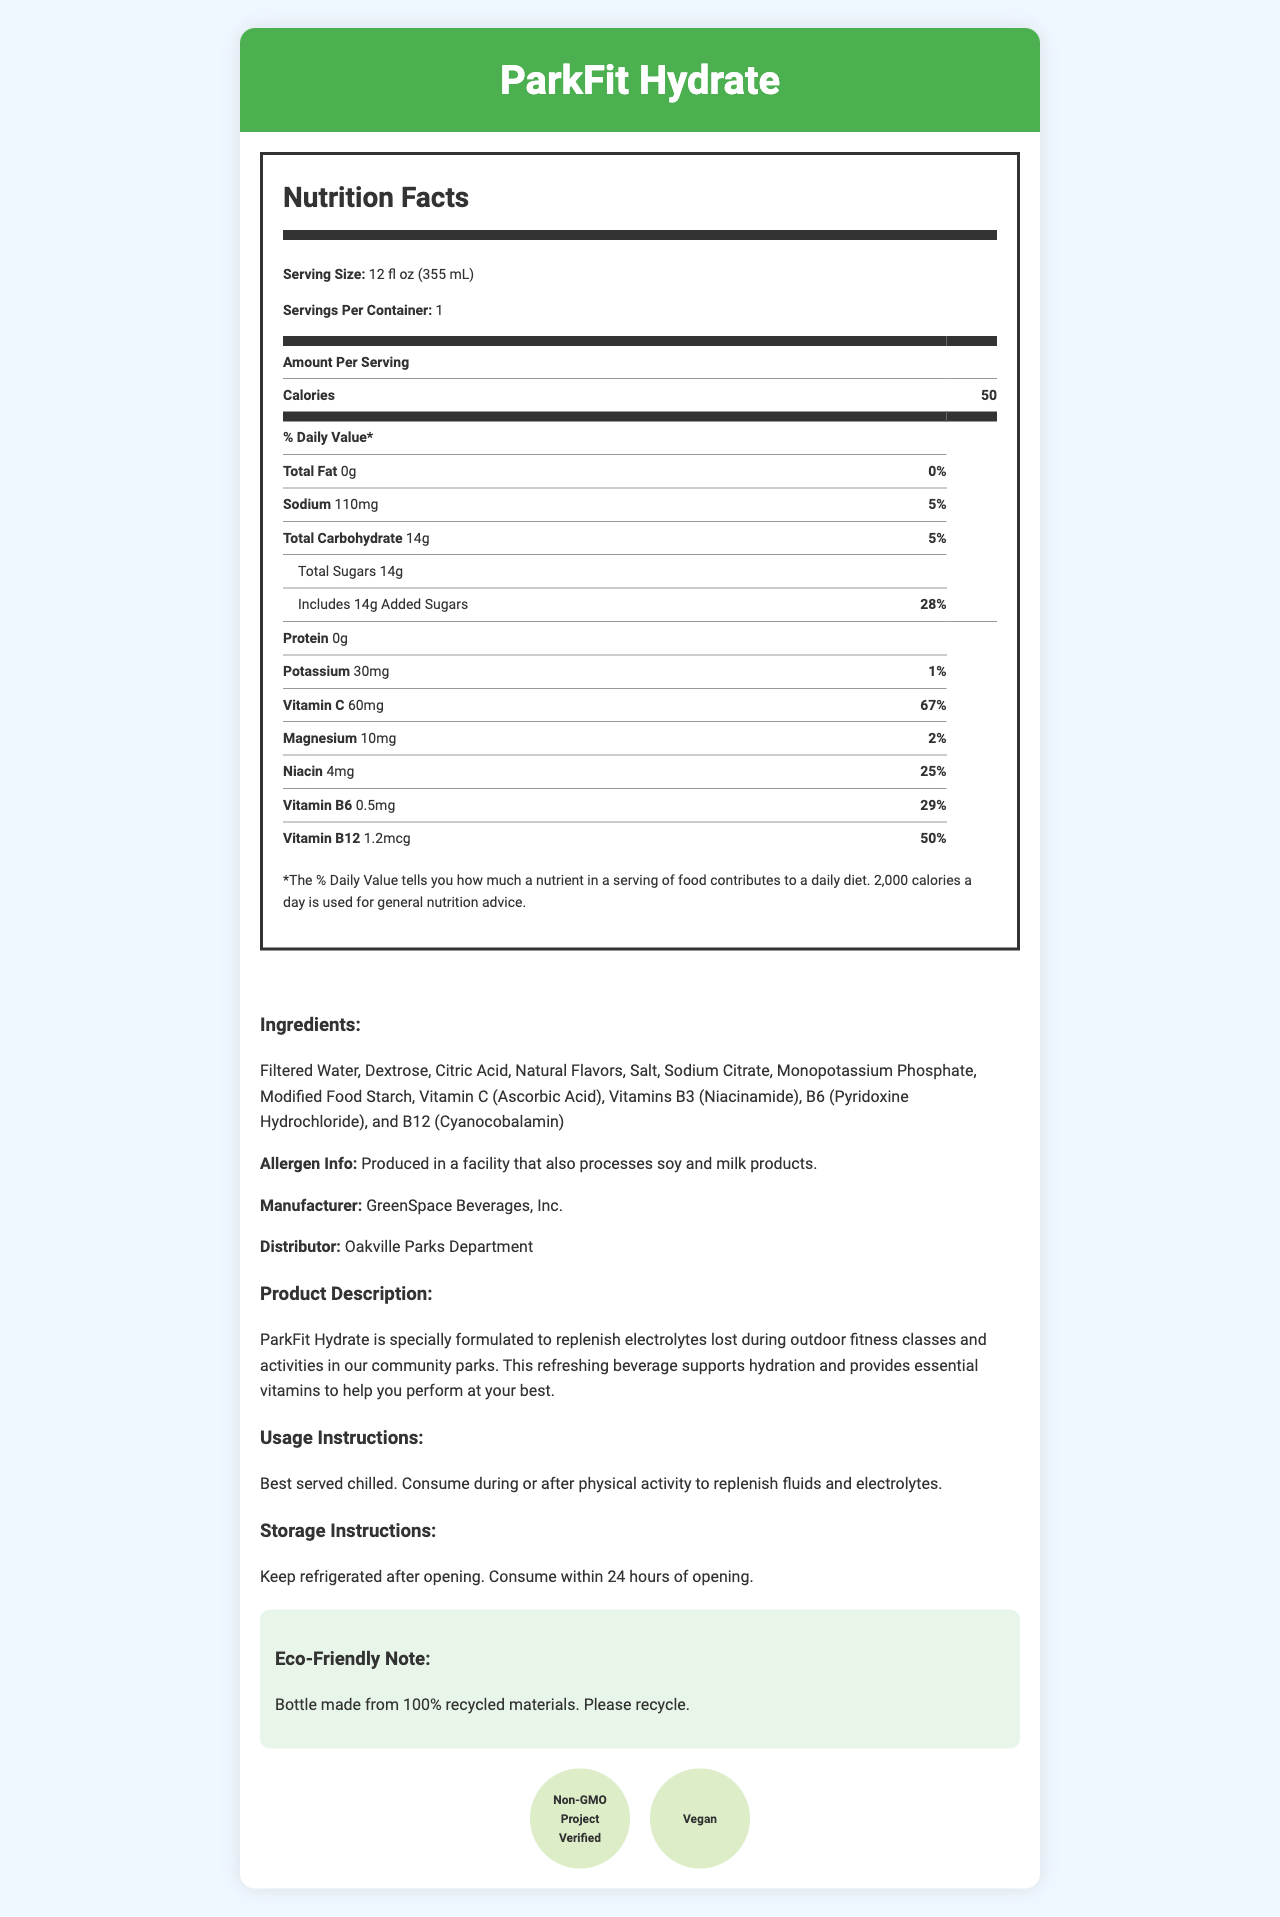what is the serving size for ParkFit Hydrate? The document states that the serving size is 12 fl oz (355 mL).
Answer: 12 fl oz (355 mL) How many calories are there per serving of ParkFit Hydrate? The document shows that each serving contains 50 calories.
Answer: 50 calories What is the total carbohydrate content per serving? According to the document, there are 14 grams of total carbohydrates per serving.
Answer: 14g How much Vitamin C is in ParkFit Hydrate? The document lists Vitamin C content as 60mg per serving.
Answer: 60mg What is the percentage of the daily value for sodium in ParkFit Hydrate? The document states that the sodium content represents 5% of the daily value.
Answer: 5% What are the main ingredients in ParkFit Hydrate? The document provides a list of main ingredients.
Answer: Filtered Water, Dextrose, Citric Acid, Natural Flavors, Salt, Sodium Citrate, Monopotassium Phosphate, Modified Food Starch, Vitamin C (Ascorbic Acid), Vitamins B3 (Niacinamide), B6 (Pyridoxine Hydrochloride), and B12 (Cyanocobalamin) who distributes ParkFit Hydrate? The document states that the distributor is Oakville Parks Department.
Answer: Oakville Parks Department What are the daily values for the added sugars in ParkFit Hydrate? The document indicates that added sugars account for 28% of the daily value.
Answer: 28% What allergens might be present in ParkFit Hydrate? The allergen information states that it is produced in a facility that also processes soy and milk products.
Answer: Soy and milk products Which of these vitamins has the highest % daily value in ParkFit Hydrate? A. Vitamin B6 B. Vitamin B12 C. Vitamin C D. Niacin The document shows that Vitamin C has a daily value of 67%, higher than the other listed vitamins.
Answer: Vitamin C How much protein is in a serving of ParkFit Hydrate? The document specifies that there is 0g of protein per serving.
Answer: 0g Which certification is NOT listed for ParkFit Hydrate? A. Non-GMO Project Verified B. Fair Trade C. Vegan The document lists Non-GMO Project Verified and Vegan certifications but does not mention Fair Trade.
Answer: Fair Trade What is the purpose of ParkFit Hydrate according to the product description? The product description states that ParkFit Hydrate is meant to replenish electrolytes lost during outdoor fitness classes and activities in community parks.
Answer: To replenish electrolytes lost during outdoor fitness classes and activities Should ParkFit Hydrate be consumed before physical activity? According to the usage instructions, it is best consumed during or after physical activity.
Answer: No Describe the main idea of the document. The explanation for the main idea includes insights on the nutritional content, intended use, and eco-friendly aspects of ParkFit Hydrate.
Answer: The document provides detailed information about ParkFit Hydrate, including nutrition facts, ingredients, allergen information, product description, usage instructions, and certifications. It highlights that the drink is designed to support hydration and replenish electrolytes during or after physical activity. What is the price of ParkFit Hydrate per bottle? The document does not provide any details regarding the price of the product.
Answer: Not enough information 